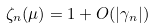<formula> <loc_0><loc_0><loc_500><loc_500>\zeta _ { n } ( \mu ) = 1 + O ( | \gamma _ { n } | )</formula> 